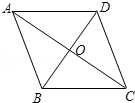How can understanding the properties of this diamond shape assist in engineering or architecture? Knowledge of the properties of a diamond or rhombus shape is critical in fields such as engineering or architecture for several reasons. The equilateral shape ensures balanced load distribution, ideal for supports and frameworks in buildings. Additionally, the perpendicular bisectors of the diagonals offer structural integrity and symmetry, facilitating robust and aesthetically pleasing constructions. 